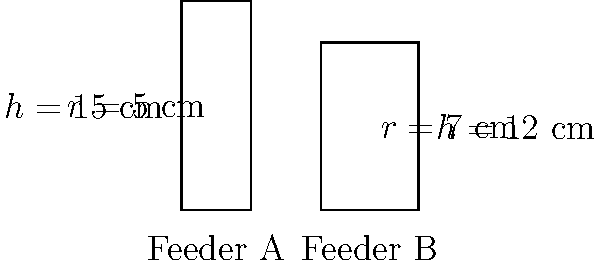As a Vienna rabbit breeder, you're comparing two cylindrical feeders for your rabbits. Feeder A has a radius of 5 cm and a height of 15 cm, while Feeder B has a radius of 7 cm and a height of 12 cm. What is the difference in volume between Feeder B and Feeder A, rounded to the nearest cubic centimeter? To solve this problem, we'll follow these steps:

1) The volume of a cylinder is given by the formula $V = \pi r^2 h$, where $r$ is the radius and $h$ is the height.

2) For Feeder A:
   $V_A = \pi (5\text{ cm})^2 (15\text{ cm})$
   $V_A = \pi (25\text{ cm}^2) (15\text{ cm})$
   $V_A = 375\pi \text{ cm}^3$

3) For Feeder B:
   $V_B = \pi (7\text{ cm})^2 (12\text{ cm})$
   $V_B = \pi (49\text{ cm}^2) (12\text{ cm})$
   $V_B = 588\pi \text{ cm}^3$

4) The difference in volume is:
   $V_B - V_A = 588\pi \text{ cm}^3 - 375\pi \text{ cm}^3 = 213\pi \text{ cm}^3$

5) To calculate this:
   $213\pi \approx 668.73 \text{ cm}^3$

6) Rounding to the nearest cubic centimeter:
   $668.73 \text{ cm}^3 \approx 669 \text{ cm}^3$

Therefore, Feeder B has a volume approximately 669 cubic centimeters larger than Feeder A.
Answer: 669 cm³ 